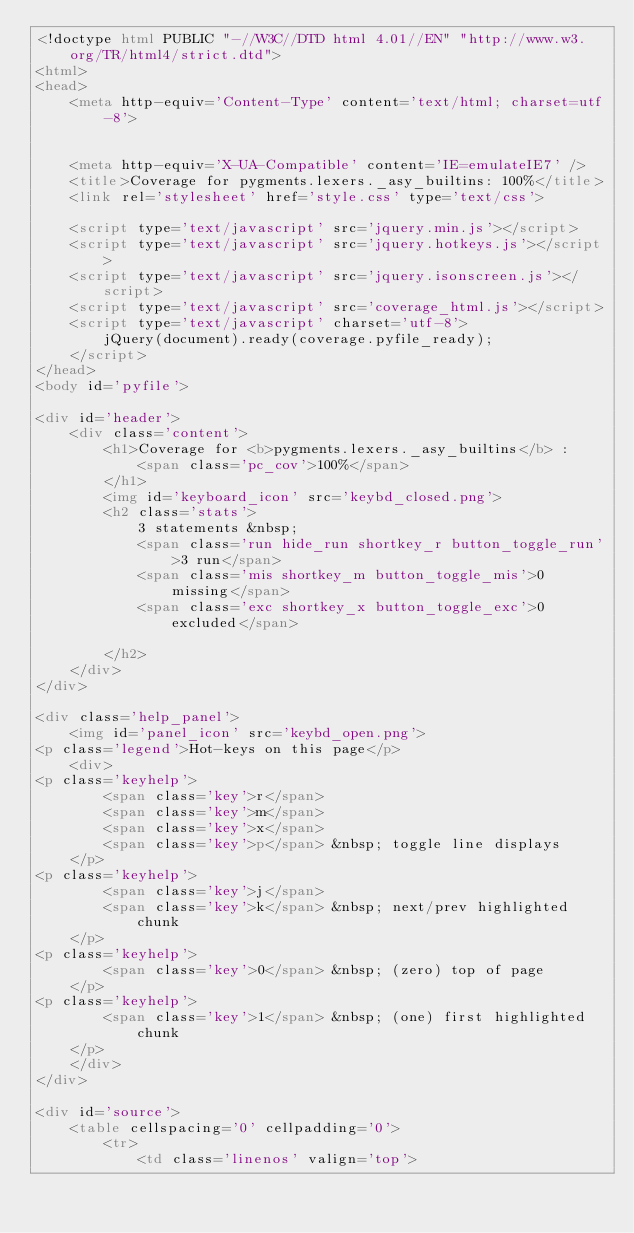Convert code to text. <code><loc_0><loc_0><loc_500><loc_500><_HTML_><!doctype html PUBLIC "-//W3C//DTD html 4.01//EN" "http://www.w3.org/TR/html4/strict.dtd">
<html>
<head>
    <meta http-equiv='Content-Type' content='text/html; charset=utf-8'>
    
    
    <meta http-equiv='X-UA-Compatible' content='IE=emulateIE7' />
    <title>Coverage for pygments.lexers._asy_builtins: 100%</title>
    <link rel='stylesheet' href='style.css' type='text/css'>
    
    <script type='text/javascript' src='jquery.min.js'></script>
    <script type='text/javascript' src='jquery.hotkeys.js'></script>
    <script type='text/javascript' src='jquery.isonscreen.js'></script>
    <script type='text/javascript' src='coverage_html.js'></script>
    <script type='text/javascript' charset='utf-8'>
        jQuery(document).ready(coverage.pyfile_ready);
    </script>
</head>
<body id='pyfile'>

<div id='header'>
    <div class='content'>
        <h1>Coverage for <b>pygments.lexers._asy_builtins</b> :
            <span class='pc_cov'>100%</span>
        </h1>
        <img id='keyboard_icon' src='keybd_closed.png'>
        <h2 class='stats'>
            3 statements &nbsp;
            <span class='run hide_run shortkey_r button_toggle_run'>3 run</span>
            <span class='mis shortkey_m button_toggle_mis'>0 missing</span>
            <span class='exc shortkey_x button_toggle_exc'>0 excluded</span>
            
        </h2>
    </div>
</div>

<div class='help_panel'>
    <img id='panel_icon' src='keybd_open.png'>
<p class='legend'>Hot-keys on this page</p>
    <div>
<p class='keyhelp'>
        <span class='key'>r</span>
        <span class='key'>m</span>
        <span class='key'>x</span>
        <span class='key'>p</span> &nbsp; toggle line displays
    </p>
<p class='keyhelp'>
        <span class='key'>j</span>
        <span class='key'>k</span> &nbsp; next/prev highlighted chunk
    </p>
<p class='keyhelp'>
        <span class='key'>0</span> &nbsp; (zero) top of page
    </p>
<p class='keyhelp'>
        <span class='key'>1</span> &nbsp; (one) first highlighted chunk
    </p>
    </div>
</div>

<div id='source'>
    <table cellspacing='0' cellpadding='0'>
        <tr>
            <td class='linenos' valign='top'></code> 